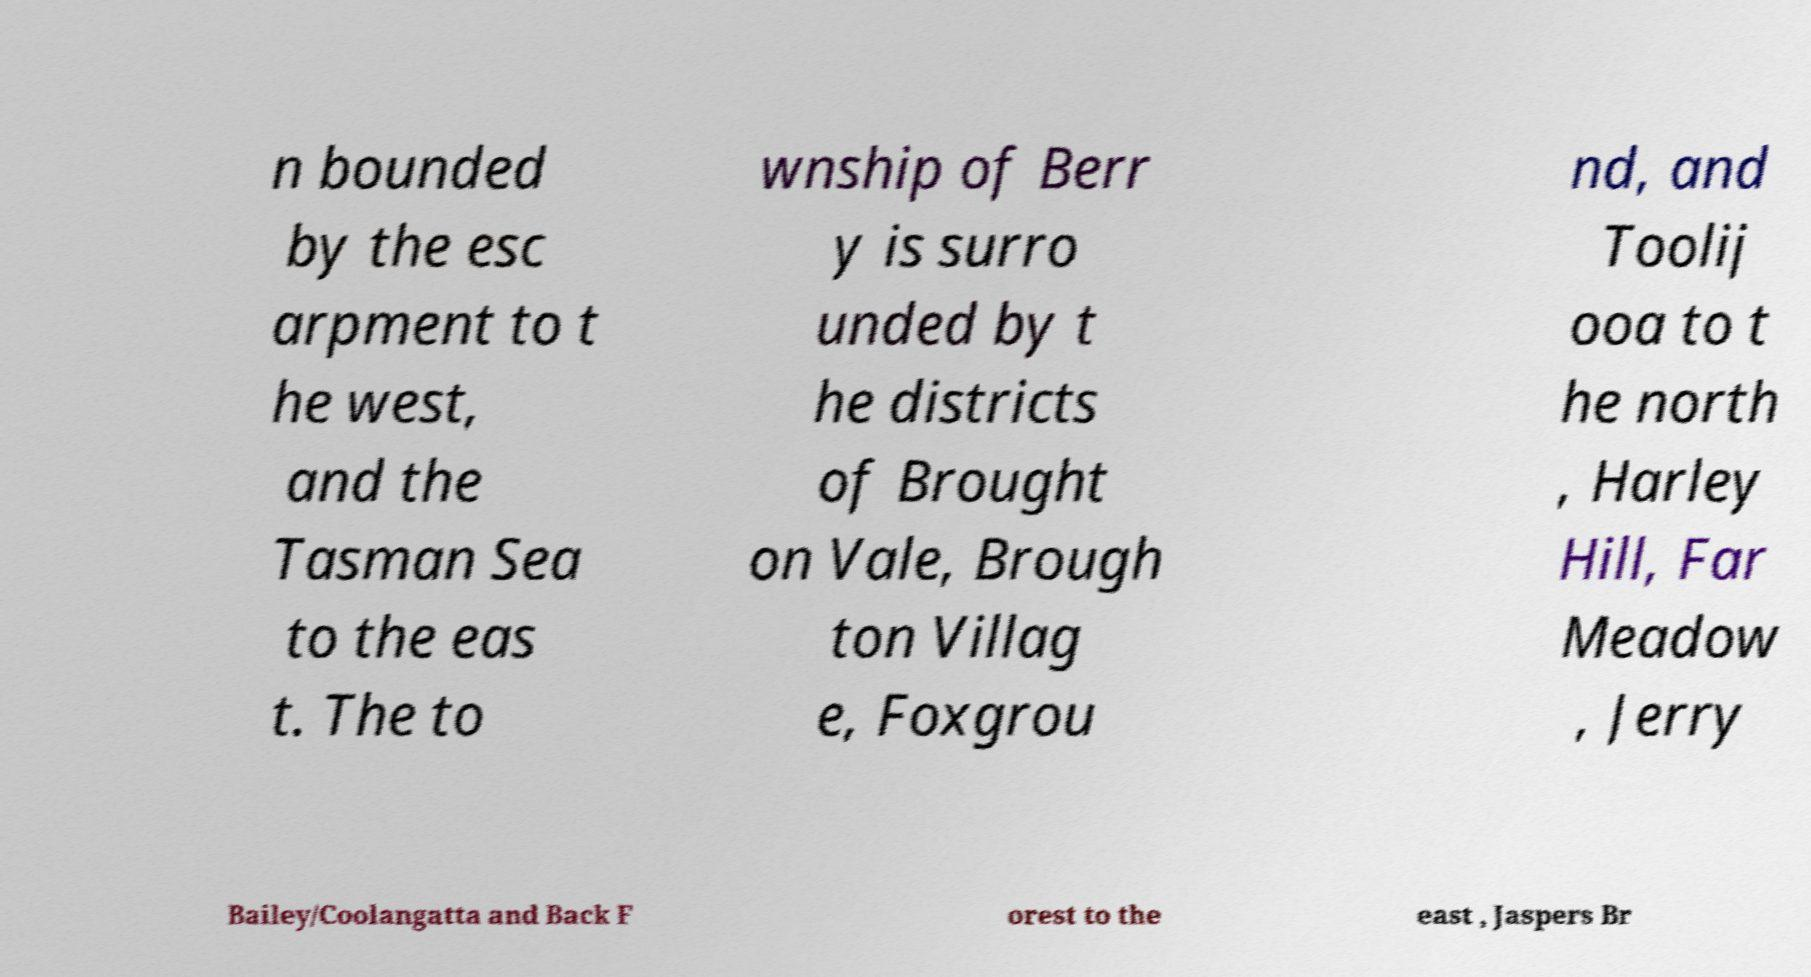Could you assist in decoding the text presented in this image and type it out clearly? n bounded by the esc arpment to t he west, and the Tasman Sea to the eas t. The to wnship of Berr y is surro unded by t he districts of Brought on Vale, Brough ton Villag e, Foxgrou nd, and Toolij ooa to t he north , Harley Hill, Far Meadow , Jerry Bailey/Coolangatta and Back F orest to the east , Jaspers Br 